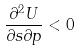Convert formula to latex. <formula><loc_0><loc_0><loc_500><loc_500>\frac { \partial ^ { 2 } U } { \partial s \partial p } < 0</formula> 